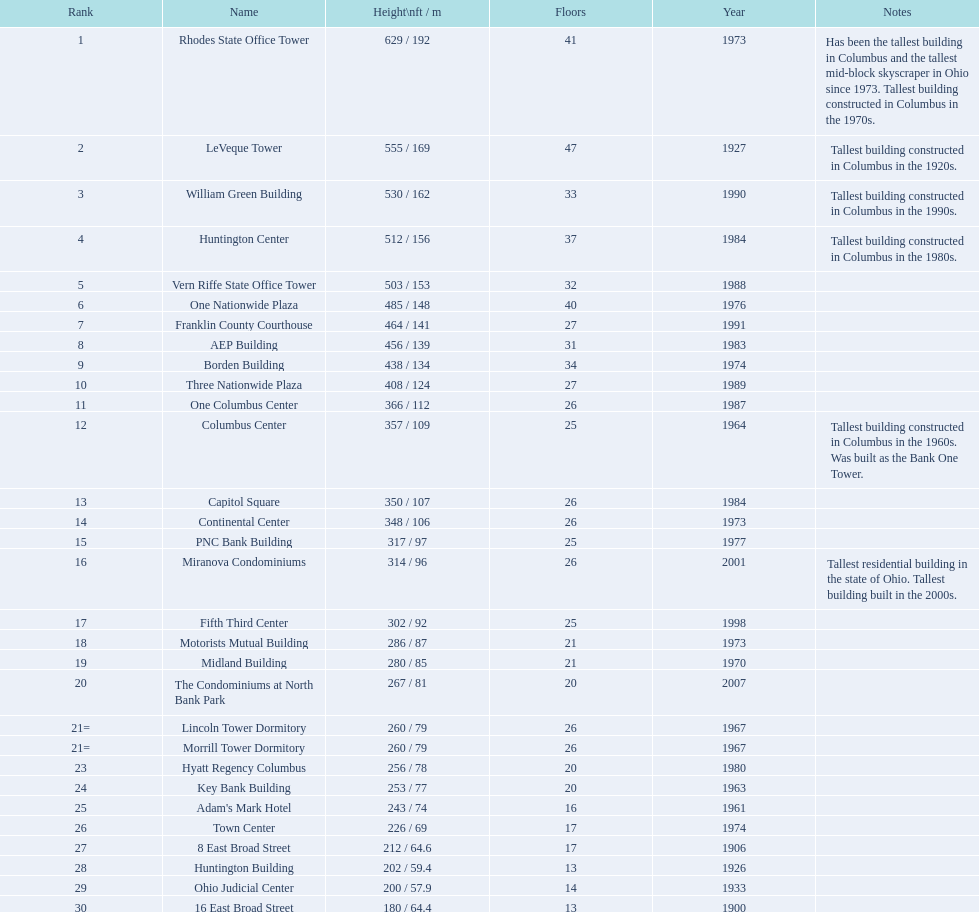What are the heights of all the buildings 629 / 192, 555 / 169, 530 / 162, 512 / 156, 503 / 153, 485 / 148, 464 / 141, 456 / 139, 438 / 134, 408 / 124, 366 / 112, 357 / 109, 350 / 107, 348 / 106, 317 / 97, 314 / 96, 302 / 92, 286 / 87, 280 / 85, 267 / 81, 260 / 79, 260 / 79, 256 / 78, 253 / 77, 243 / 74, 226 / 69, 212 / 64.6, 202 / 59.4, 200 / 57.9, 180 / 64.4. What are the heights of the aep and columbus center buildings 456 / 139, 357 / 109. Which height is greater? 456 / 139. What building is this for? AEP Building. 